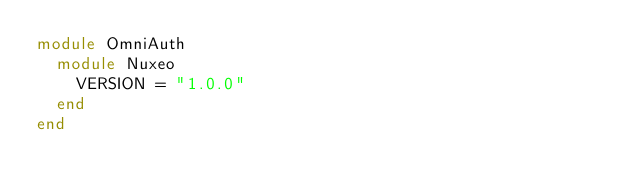<code> <loc_0><loc_0><loc_500><loc_500><_Ruby_>module OmniAuth
  module Nuxeo
    VERSION = "1.0.0"
  end
end</code> 